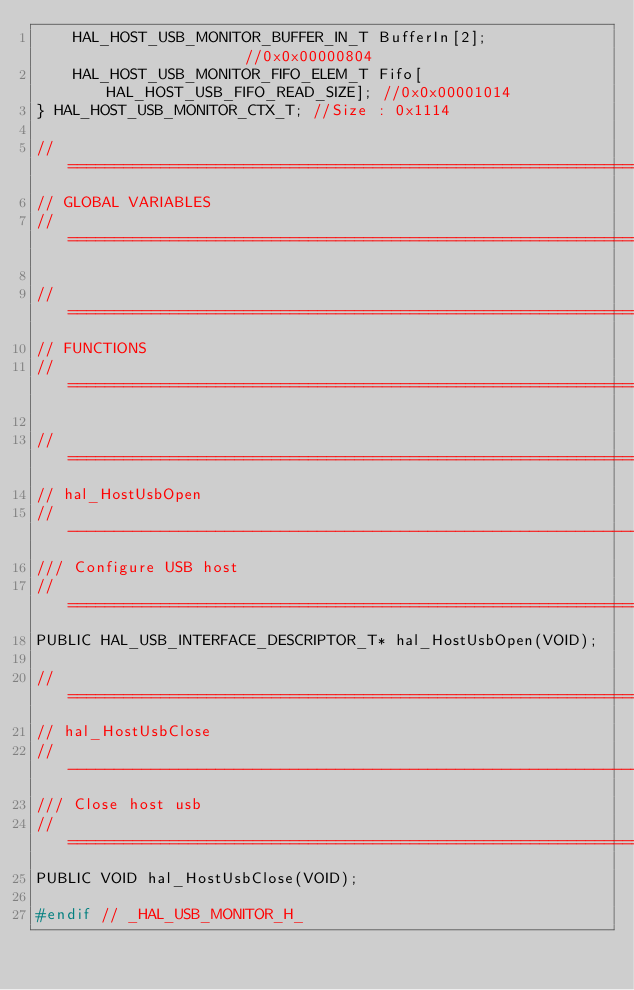<code> <loc_0><loc_0><loc_500><loc_500><_C_>    HAL_HOST_USB_MONITOR_BUFFER_IN_T BufferIn[2];                //0x0x00000804
    HAL_HOST_USB_MONITOR_FIFO_ELEM_T Fifo[HAL_HOST_USB_FIFO_READ_SIZE]; //0x0x00001014
} HAL_HOST_USB_MONITOR_CTX_T; //Size : 0x1114

// =============================================================================
// GLOBAL VARIABLES
// =============================================================================

// =============================================================================
// FUNCTIONS
// =============================================================================

// =============================================================================
// hal_HostUsbOpen
// -----------------------------------------------------------------------------
/// Configure USB host
// =============================================================================
PUBLIC HAL_USB_INTERFACE_DESCRIPTOR_T* hal_HostUsbOpen(VOID);

// =============================================================================
// hal_HostUsbClose
// -----------------------------------------------------------------------------
/// Close host usb
// =============================================================================
PUBLIC VOID hal_HostUsbClose(VOID);

#endif // _HAL_USB_MONITOR_H_
</code> 